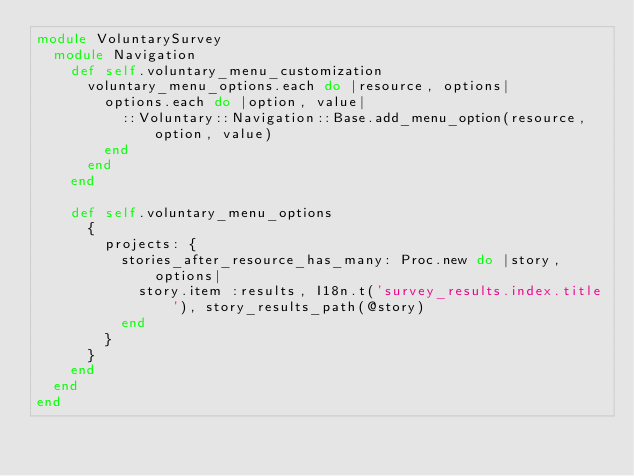Convert code to text. <code><loc_0><loc_0><loc_500><loc_500><_Ruby_>module VoluntarySurvey
  module Navigation
    def self.voluntary_menu_customization
      voluntary_menu_options.each do |resource, options|
        options.each do |option, value|
          ::Voluntary::Navigation::Base.add_menu_option(resource, option, value)
        end
      end
    end
    
    def self.voluntary_menu_options
      {
        projects: {
          stories_after_resource_has_many: Proc.new do |story, options|
            story.item :results, I18n.t('survey_results.index.title'), story_results_path(@story)  
          end
        }
      }
    end
  end
end
    </code> 